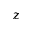<formula> <loc_0><loc_0><loc_500><loc_500>z</formula> 